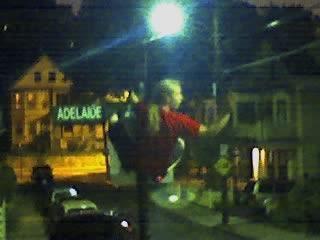How many people are in the picture?
Give a very brief answer. 1. How many women are dressed in red on the right side of the street sign?
Give a very brief answer. 1. 